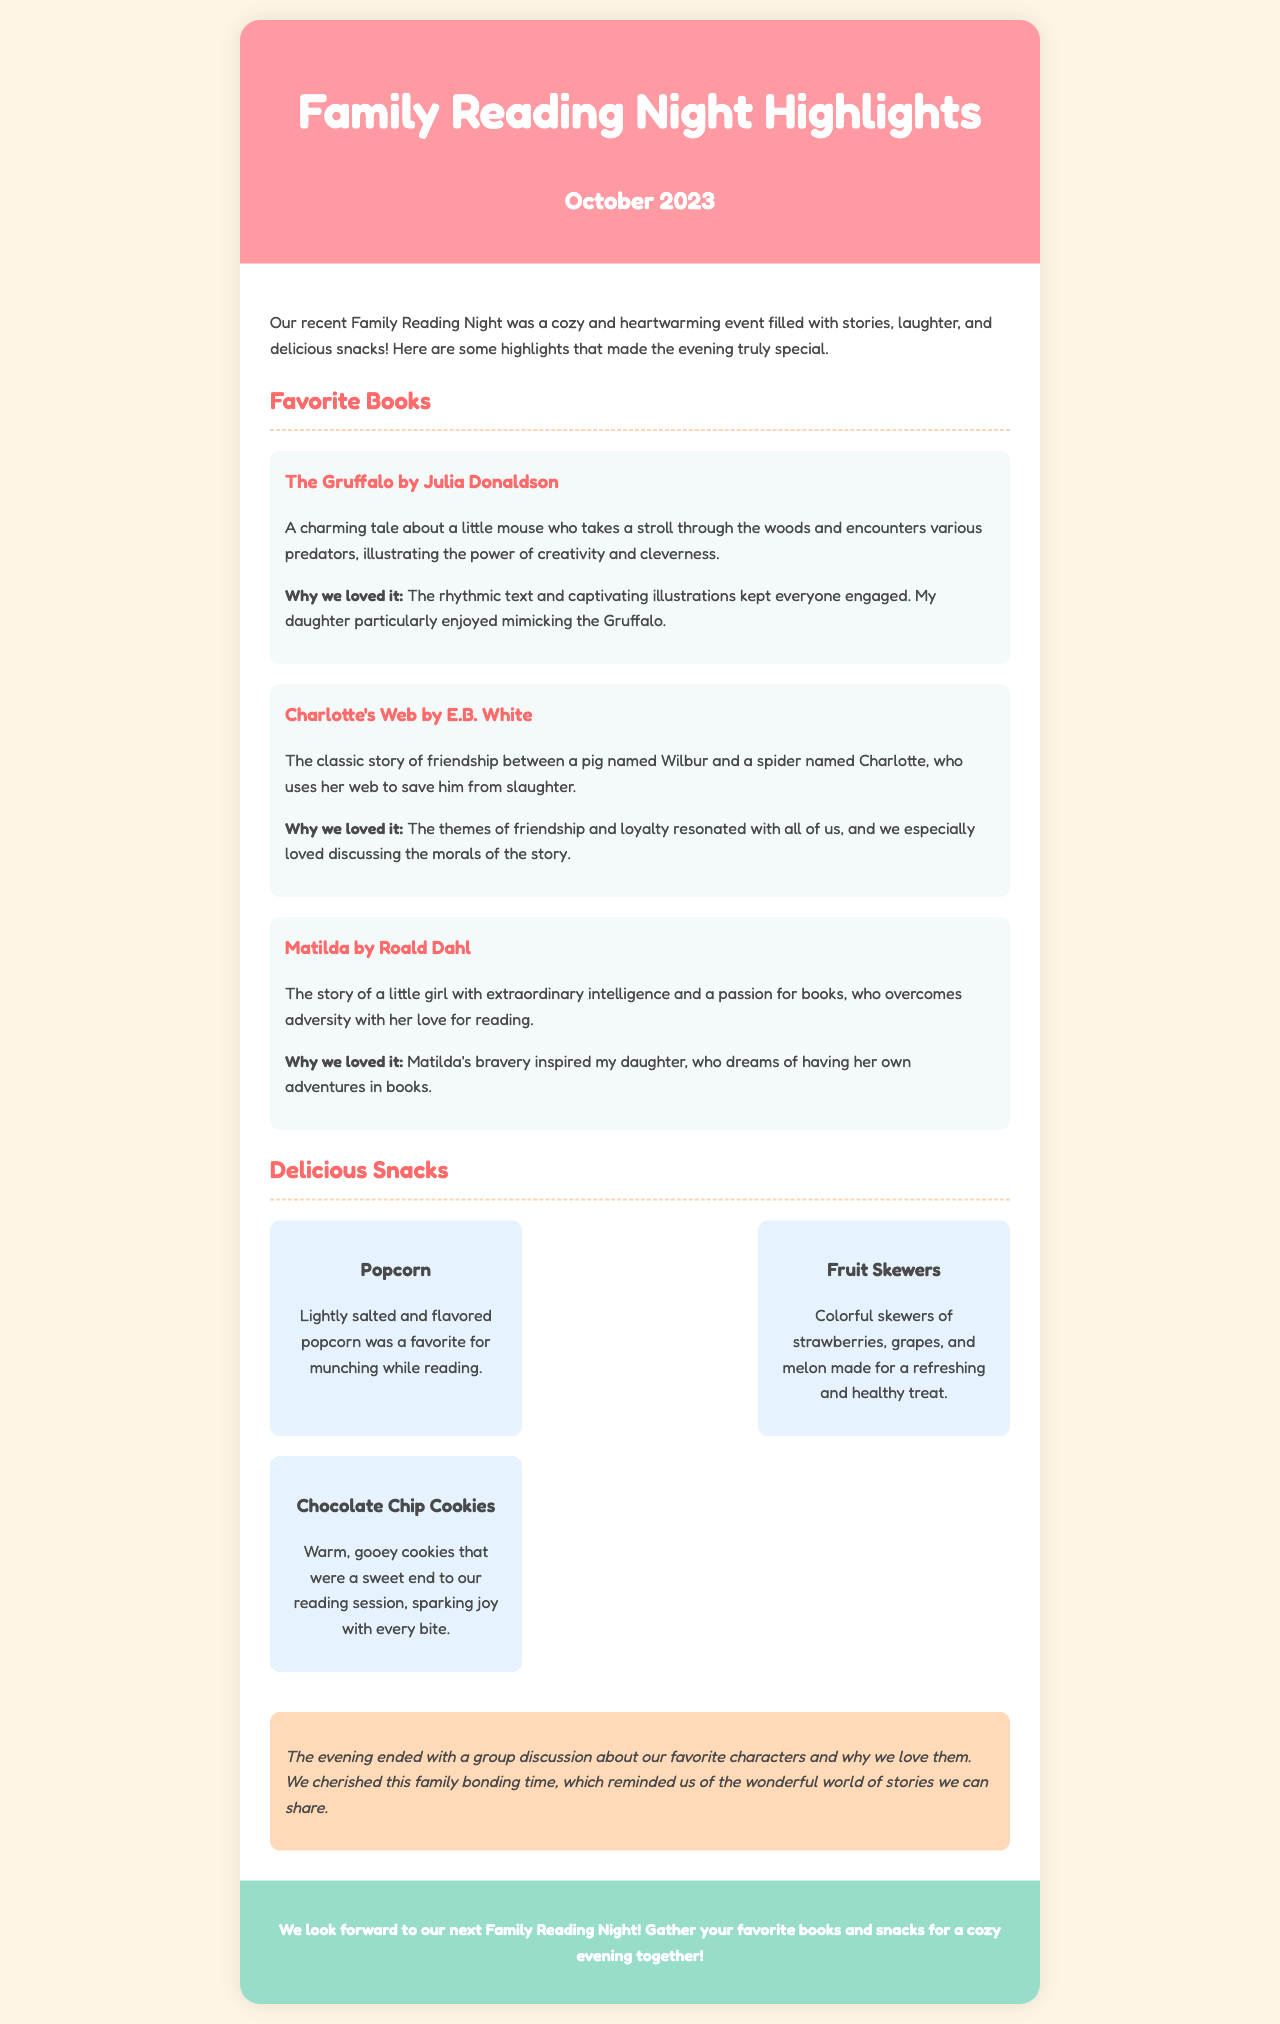What was the date of the Family Reading Night? The date is mentioned at the top of the document as October 2023.
Answer: October 2023 What is one of the favorite books mentioned? The document lists several favorite books; one example is "The Gruffalo."
Answer: The Gruffalo What type of snacks were served? The document describes various snacks including popcorn, fruit skewers, and chocolate chip cookies.
Answer: Popcorn Which book features a spider named Charlotte? The document describes "Charlotte's Web," which features Charlotte as a character.
Answer: Charlotte's Web What memory did the family cherish from the evening? The document states that they cherished a group discussion about favorite characters.
Answer: Group discussion about favorite characters What snack is described as a refreshing treat? The document specifically mentions fruit skewers as a refreshing treat.
Answer: Fruit Skewers Why did they love "Matilda"? The document states that Matilda's bravery inspired the writer's daughter.
Answer: Matilda's bravery How many favorite books are highlighted in the document? The document highlights three favorite books from the reading night event.
Answer: Three 